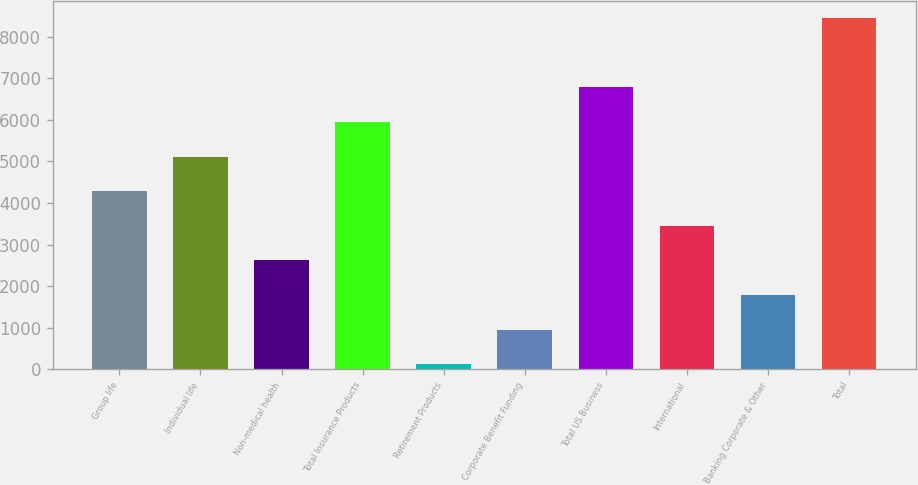Convert chart. <chart><loc_0><loc_0><loc_500><loc_500><bar_chart><fcel>Group life<fcel>Individual life<fcel>Non-medical health<fcel>Total Insurance Products<fcel>Retirement Products<fcel>Corporate Benefit Funding<fcel>Total US Business<fcel>International<fcel>Banking Corporate & Other<fcel>Total<nl><fcel>4284<fcel>5116.4<fcel>2619.2<fcel>5948.8<fcel>122<fcel>954.4<fcel>6781.2<fcel>3451.6<fcel>1786.8<fcel>8446<nl></chart> 